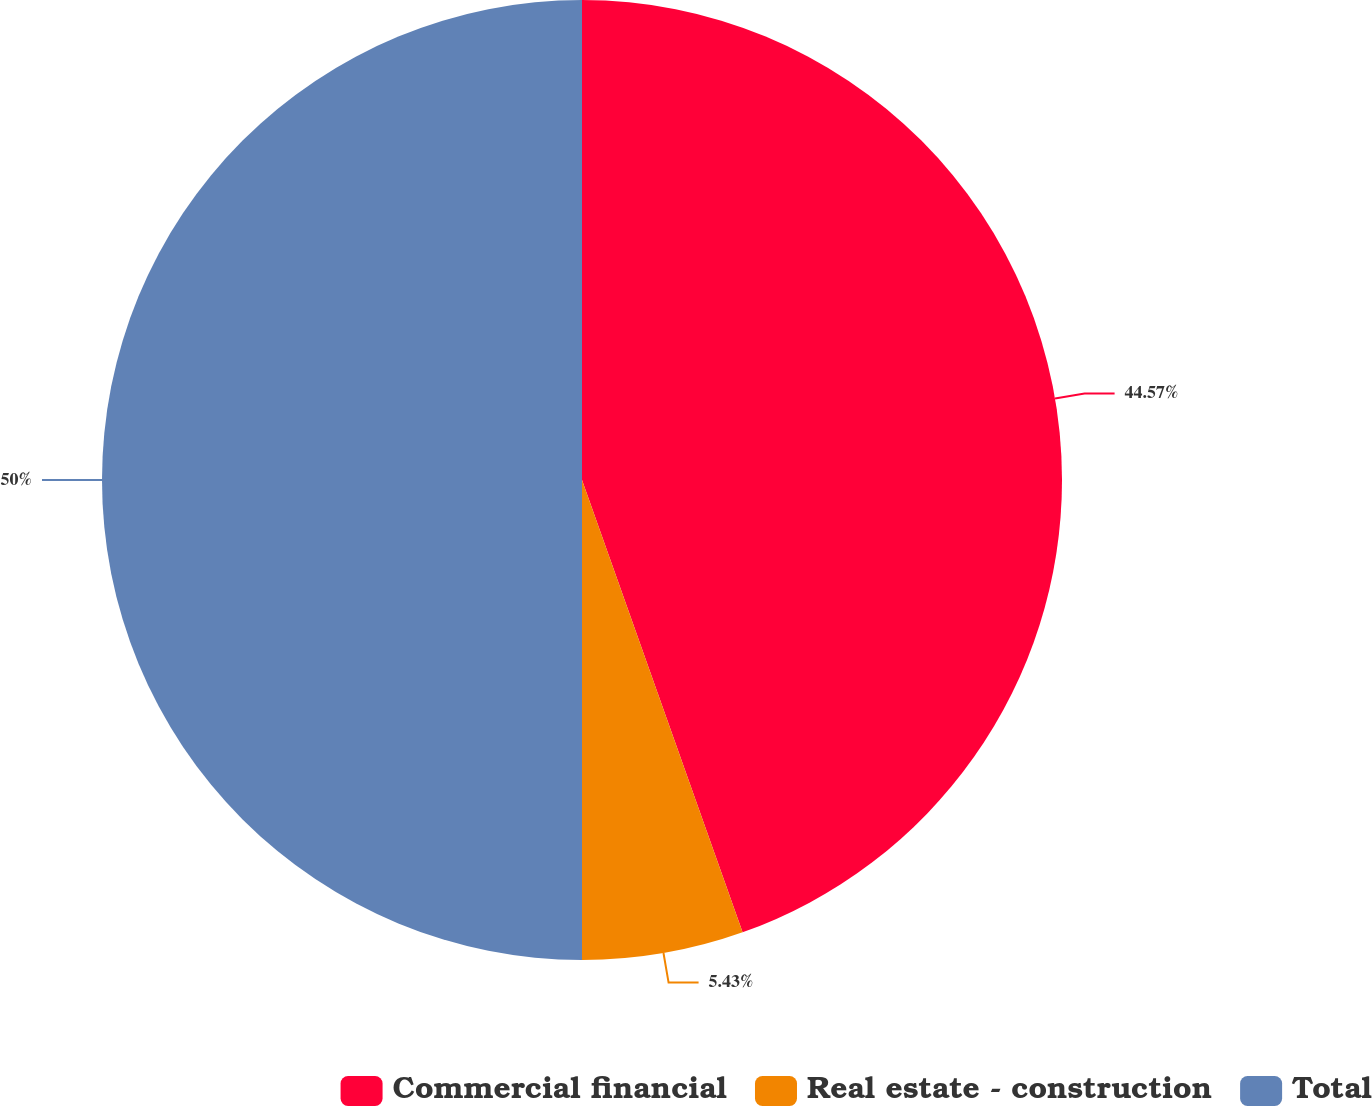Convert chart to OTSL. <chart><loc_0><loc_0><loc_500><loc_500><pie_chart><fcel>Commercial financial<fcel>Real estate - construction<fcel>Total<nl><fcel>44.57%<fcel>5.43%<fcel>50.0%<nl></chart> 